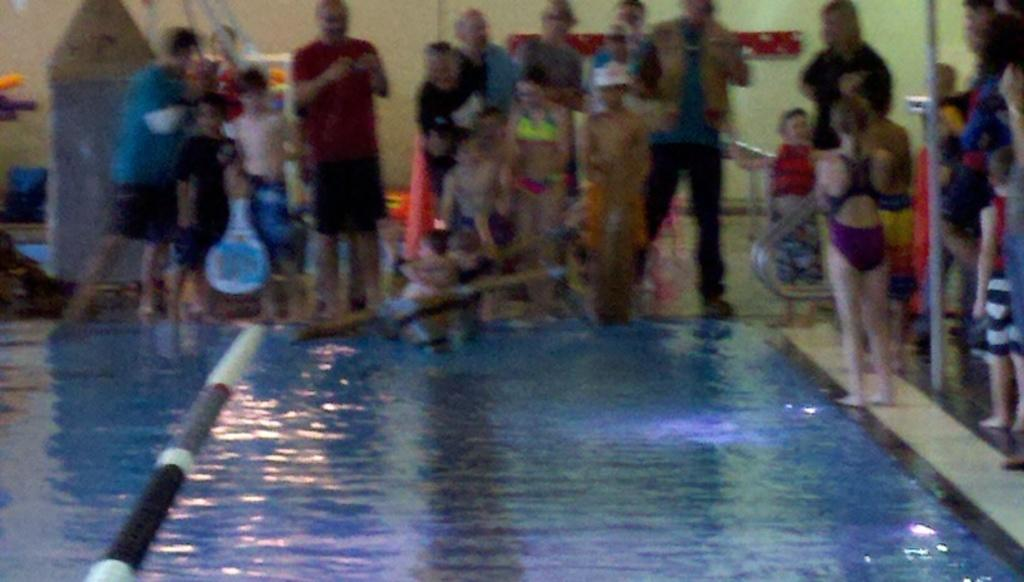What is the main feature in the image? There is a swimming pool in the image. What are the people near the swimming pool doing? The people are standing beside the swimming pool. What type of clothing are the people wearing? The people are wearing swimming suits. How many dogs are swimming in the pool in the image? There are no dogs present in the image; it features a swimming pool with people standing beside it. What type of stem can be seen growing near the pool? There is no stem visible in the image; it only shows a swimming pool and people standing beside it. 